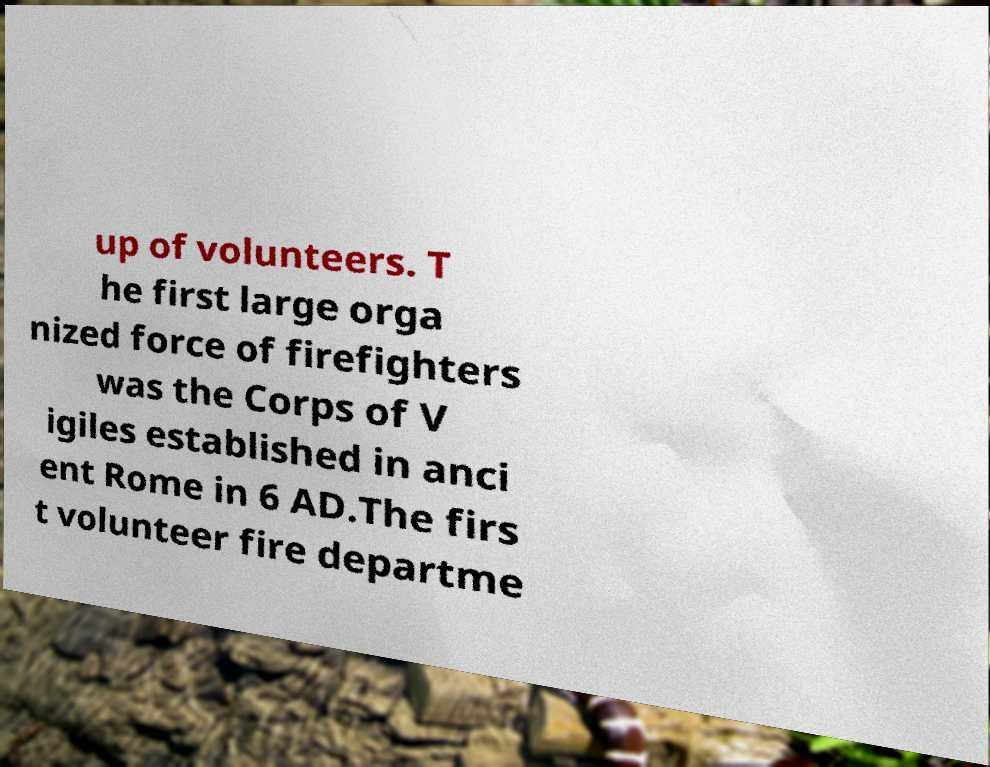For documentation purposes, I need the text within this image transcribed. Could you provide that? up of volunteers. T he first large orga nized force of firefighters was the Corps of V igiles established in anci ent Rome in 6 AD.The firs t volunteer fire departme 